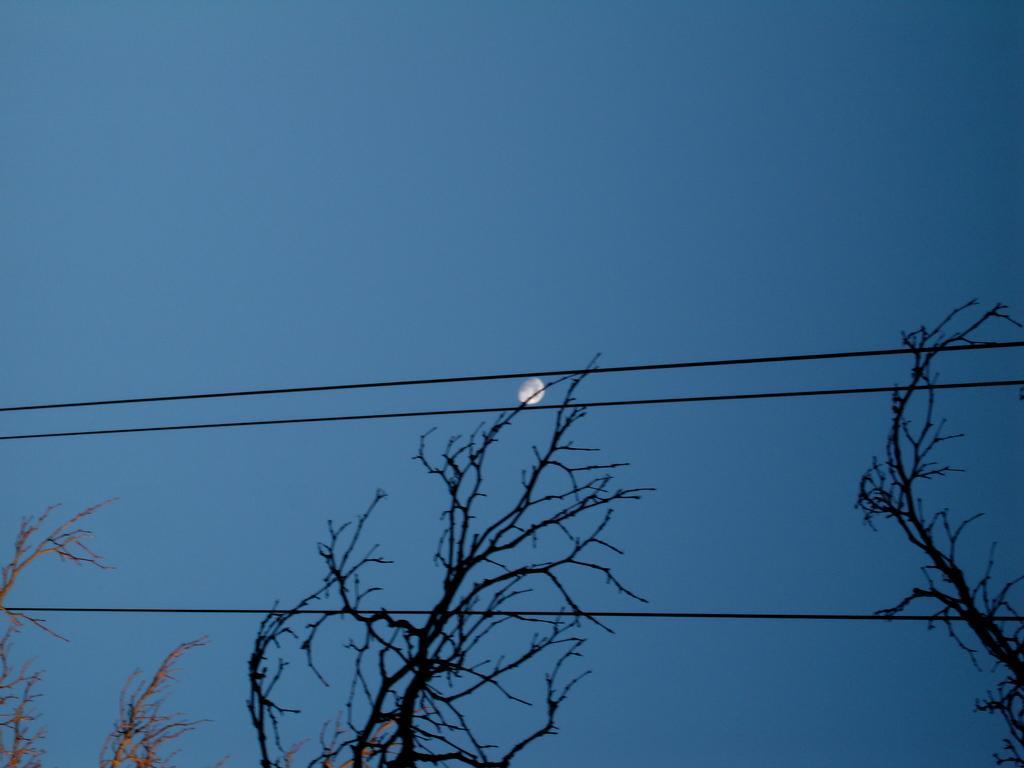Can you describe this image briefly? On the bottom of the image we can see some trees and wires, behind it there is a moon in the sky. 